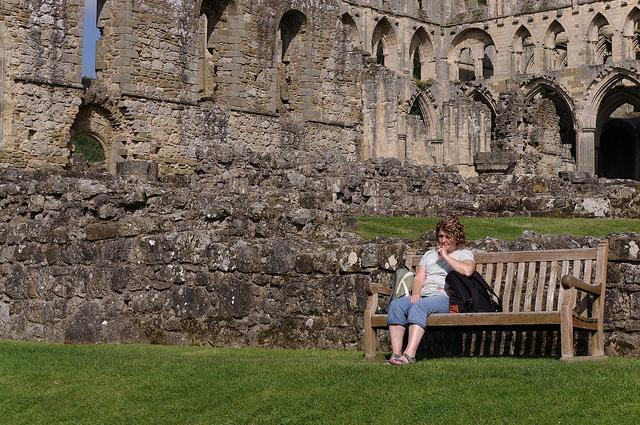What activity happens near and in this structure?

Choices:
A) baseball
B) tourism
C) office work
D) banking tourism 